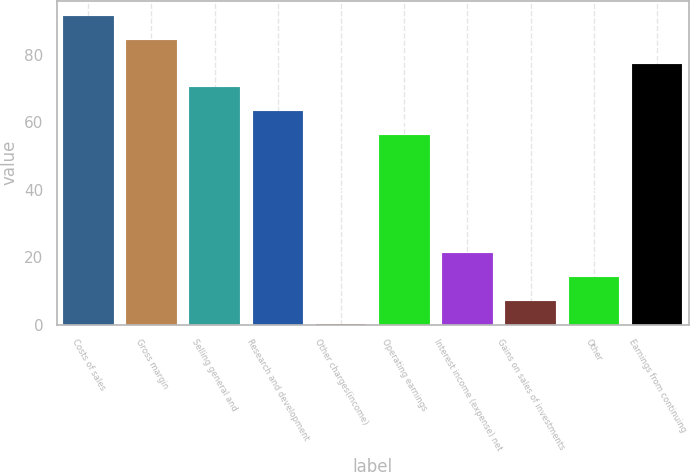Convert chart. <chart><loc_0><loc_0><loc_500><loc_500><bar_chart><fcel>Costs of sales<fcel>Gross margin<fcel>Selling general and<fcel>Research and development<fcel>Other charges(income)<fcel>Operating earnings<fcel>Interest income (expense) net<fcel>Gains on sales of investments<fcel>Other<fcel>Earnings from continuing<nl><fcel>91.36<fcel>84.34<fcel>70.3<fcel>63.28<fcel>0.1<fcel>56.26<fcel>21.16<fcel>7.12<fcel>14.14<fcel>77.32<nl></chart> 